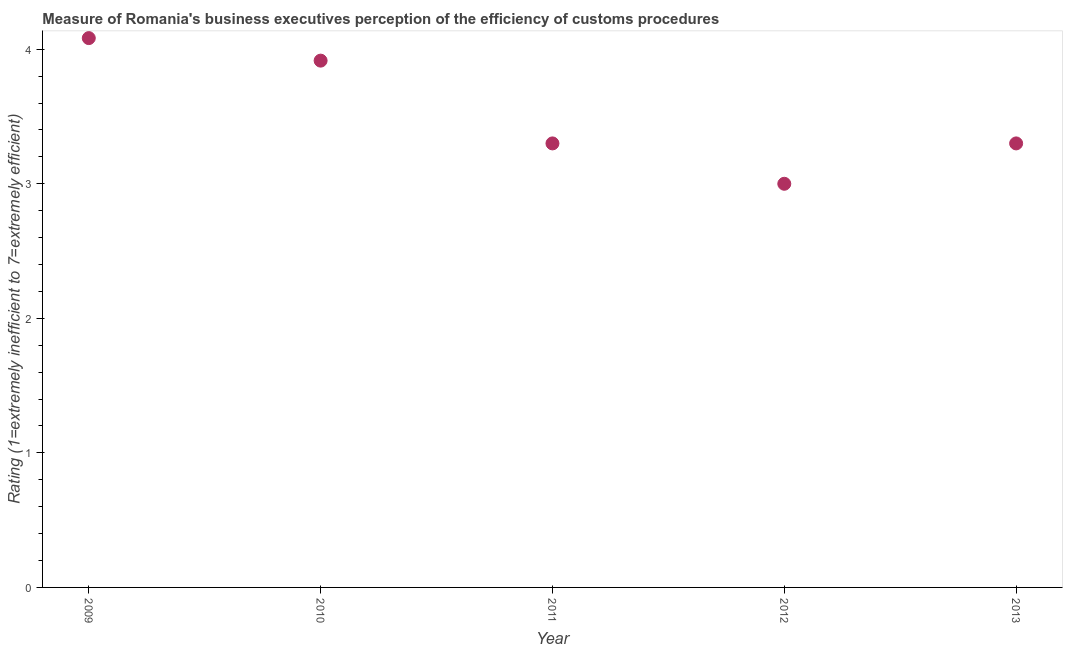What is the rating measuring burden of customs procedure in 2013?
Give a very brief answer. 3.3. Across all years, what is the maximum rating measuring burden of customs procedure?
Your answer should be very brief. 4.08. Across all years, what is the minimum rating measuring burden of customs procedure?
Keep it short and to the point. 3. In which year was the rating measuring burden of customs procedure minimum?
Offer a terse response. 2012. What is the sum of the rating measuring burden of customs procedure?
Your response must be concise. 17.6. What is the difference between the rating measuring burden of customs procedure in 2010 and 2012?
Give a very brief answer. 0.92. What is the average rating measuring burden of customs procedure per year?
Provide a succinct answer. 3.52. In how many years, is the rating measuring burden of customs procedure greater than 1.8 ?
Ensure brevity in your answer.  5. What is the ratio of the rating measuring burden of customs procedure in 2011 to that in 2012?
Ensure brevity in your answer.  1.1. Is the rating measuring burden of customs procedure in 2012 less than that in 2013?
Your response must be concise. Yes. Is the difference between the rating measuring burden of customs procedure in 2011 and 2012 greater than the difference between any two years?
Make the answer very short. No. What is the difference between the highest and the second highest rating measuring burden of customs procedure?
Offer a terse response. 0.17. Is the sum of the rating measuring burden of customs procedure in 2009 and 2010 greater than the maximum rating measuring burden of customs procedure across all years?
Ensure brevity in your answer.  Yes. What is the difference between the highest and the lowest rating measuring burden of customs procedure?
Your answer should be very brief. 1.08. Does the rating measuring burden of customs procedure monotonically increase over the years?
Give a very brief answer. No. Are the values on the major ticks of Y-axis written in scientific E-notation?
Provide a short and direct response. No. What is the title of the graph?
Make the answer very short. Measure of Romania's business executives perception of the efficiency of customs procedures. What is the label or title of the X-axis?
Your response must be concise. Year. What is the label or title of the Y-axis?
Your response must be concise. Rating (1=extremely inefficient to 7=extremely efficient). What is the Rating (1=extremely inefficient to 7=extremely efficient) in 2009?
Your response must be concise. 4.08. What is the Rating (1=extremely inefficient to 7=extremely efficient) in 2010?
Your answer should be compact. 3.92. What is the Rating (1=extremely inefficient to 7=extremely efficient) in 2012?
Keep it short and to the point. 3. What is the difference between the Rating (1=extremely inefficient to 7=extremely efficient) in 2009 and 2010?
Offer a very short reply. 0.17. What is the difference between the Rating (1=extremely inefficient to 7=extremely efficient) in 2009 and 2011?
Provide a short and direct response. 0.78. What is the difference between the Rating (1=extremely inefficient to 7=extremely efficient) in 2009 and 2012?
Ensure brevity in your answer.  1.08. What is the difference between the Rating (1=extremely inefficient to 7=extremely efficient) in 2009 and 2013?
Your response must be concise. 0.78. What is the difference between the Rating (1=extremely inefficient to 7=extremely efficient) in 2010 and 2011?
Provide a short and direct response. 0.62. What is the difference between the Rating (1=extremely inefficient to 7=extremely efficient) in 2010 and 2012?
Provide a short and direct response. 0.92. What is the difference between the Rating (1=extremely inefficient to 7=extremely efficient) in 2010 and 2013?
Ensure brevity in your answer.  0.62. What is the difference between the Rating (1=extremely inefficient to 7=extremely efficient) in 2011 and 2013?
Provide a succinct answer. 0. What is the difference between the Rating (1=extremely inefficient to 7=extremely efficient) in 2012 and 2013?
Offer a very short reply. -0.3. What is the ratio of the Rating (1=extremely inefficient to 7=extremely efficient) in 2009 to that in 2010?
Your answer should be very brief. 1.04. What is the ratio of the Rating (1=extremely inefficient to 7=extremely efficient) in 2009 to that in 2011?
Your answer should be compact. 1.24. What is the ratio of the Rating (1=extremely inefficient to 7=extremely efficient) in 2009 to that in 2012?
Your answer should be compact. 1.36. What is the ratio of the Rating (1=extremely inefficient to 7=extremely efficient) in 2009 to that in 2013?
Provide a succinct answer. 1.24. What is the ratio of the Rating (1=extremely inefficient to 7=extremely efficient) in 2010 to that in 2011?
Give a very brief answer. 1.19. What is the ratio of the Rating (1=extremely inefficient to 7=extremely efficient) in 2010 to that in 2012?
Your answer should be very brief. 1.3. What is the ratio of the Rating (1=extremely inefficient to 7=extremely efficient) in 2010 to that in 2013?
Provide a succinct answer. 1.19. What is the ratio of the Rating (1=extremely inefficient to 7=extremely efficient) in 2011 to that in 2012?
Make the answer very short. 1.1. What is the ratio of the Rating (1=extremely inefficient to 7=extremely efficient) in 2011 to that in 2013?
Offer a very short reply. 1. What is the ratio of the Rating (1=extremely inefficient to 7=extremely efficient) in 2012 to that in 2013?
Your answer should be compact. 0.91. 